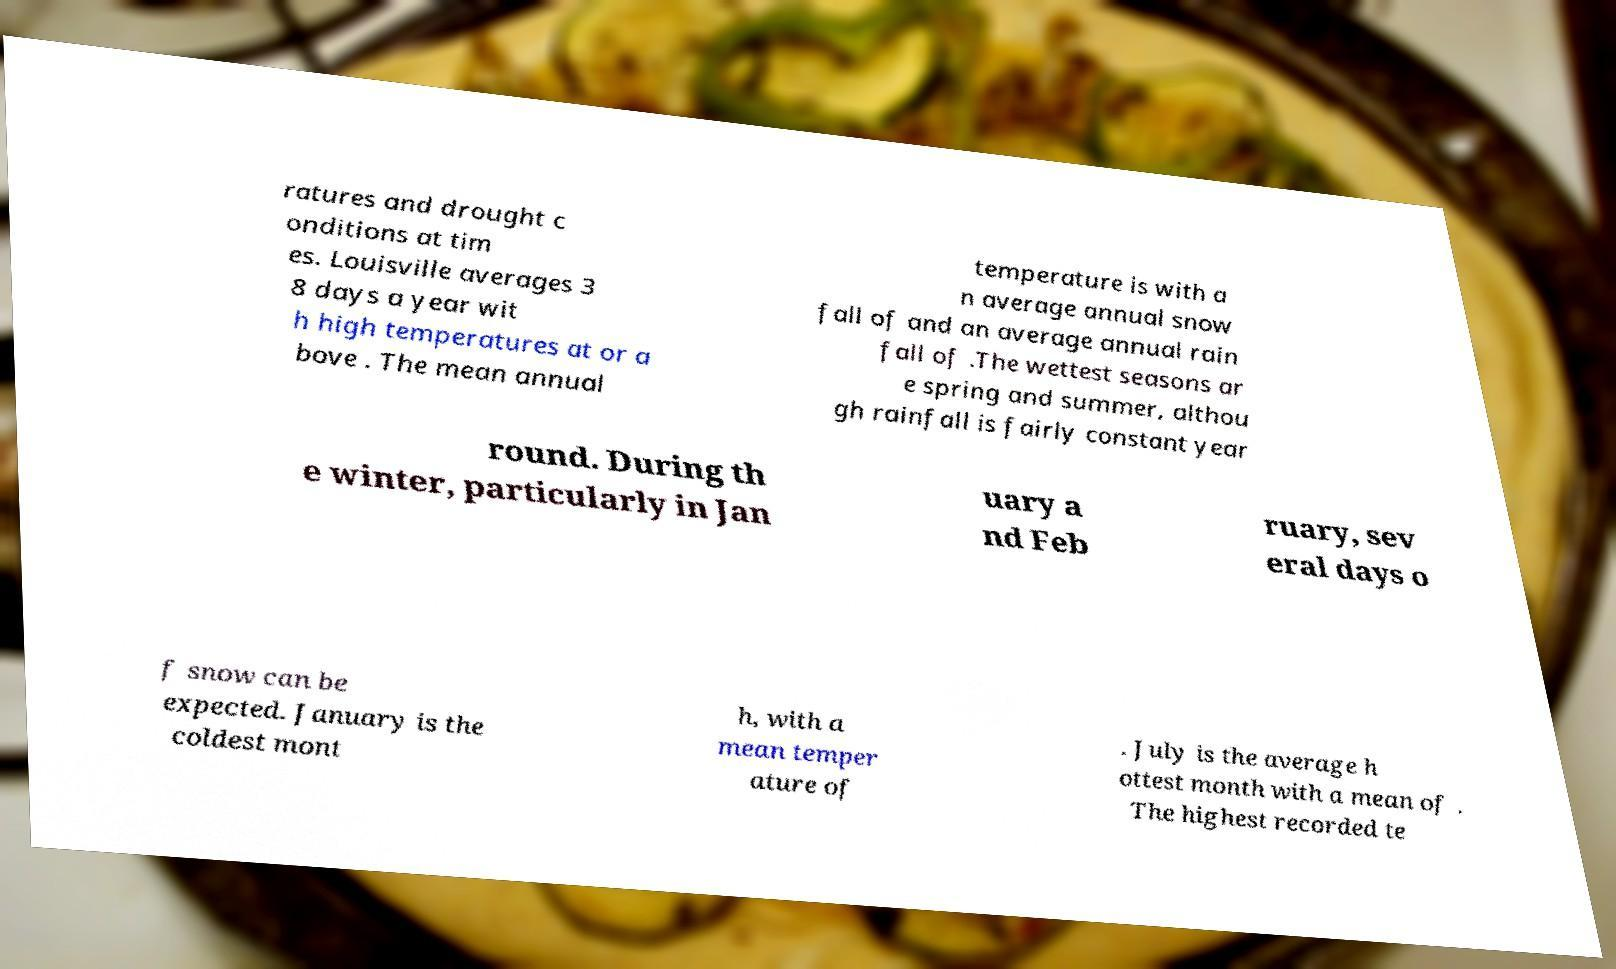What messages or text are displayed in this image? I need them in a readable, typed format. ratures and drought c onditions at tim es. Louisville averages 3 8 days a year wit h high temperatures at or a bove . The mean annual temperature is with a n average annual snow fall of and an average annual rain fall of .The wettest seasons ar e spring and summer, althou gh rainfall is fairly constant year round. During th e winter, particularly in Jan uary a nd Feb ruary, sev eral days o f snow can be expected. January is the coldest mont h, with a mean temper ature of . July is the average h ottest month with a mean of . The highest recorded te 